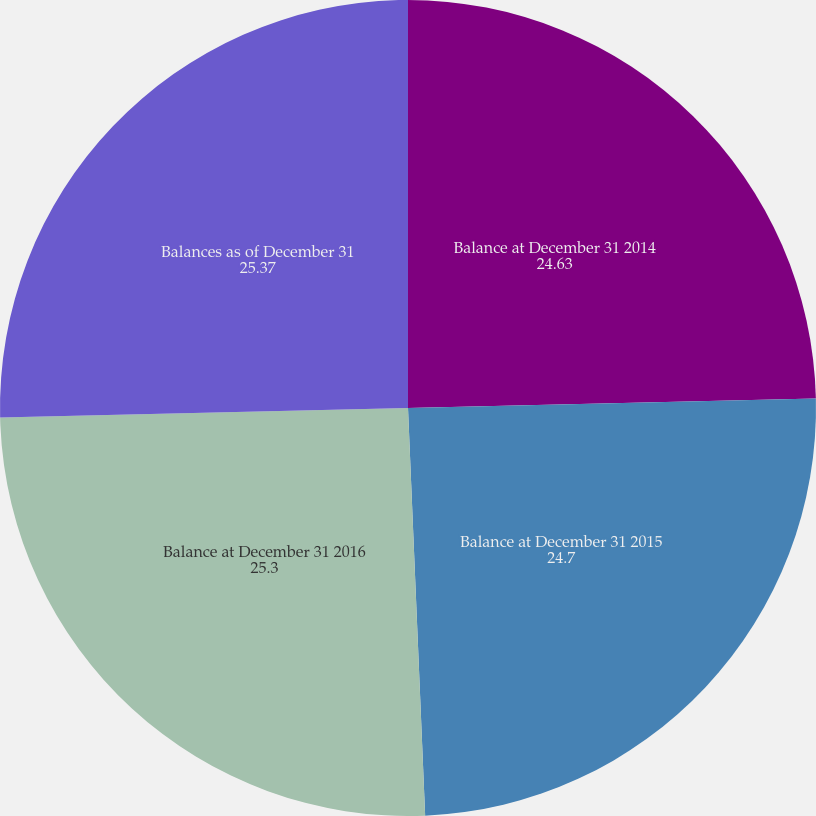Convert chart. <chart><loc_0><loc_0><loc_500><loc_500><pie_chart><fcel>Balance at December 31 2014<fcel>Balance at December 31 2015<fcel>Balance at December 31 2016<fcel>Balances as of December 31<nl><fcel>24.63%<fcel>24.7%<fcel>25.3%<fcel>25.37%<nl></chart> 